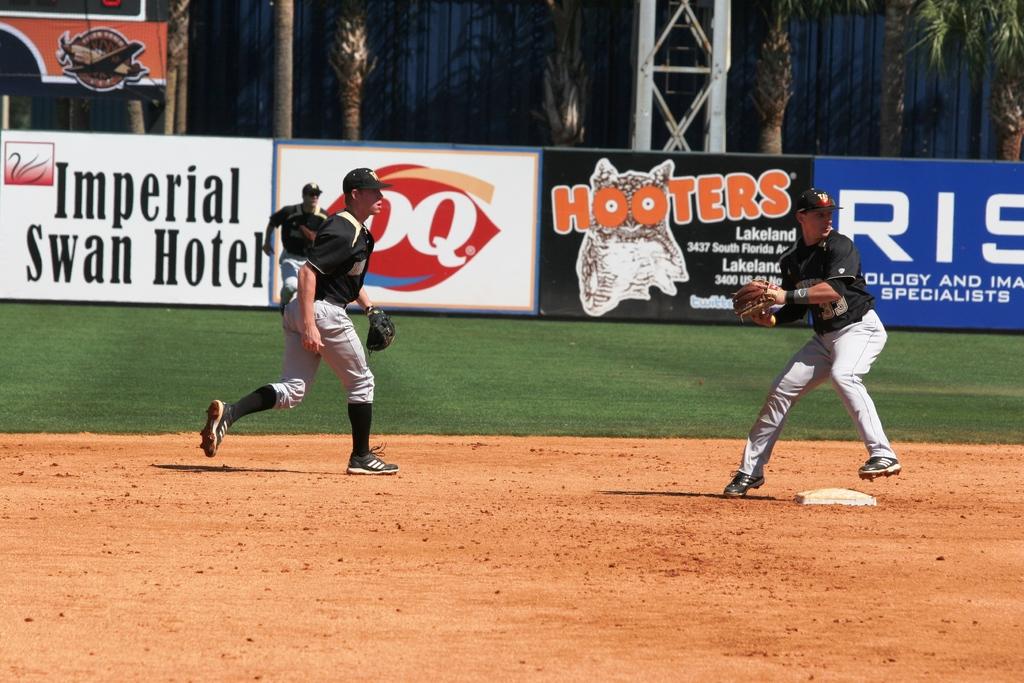What companies sponsor this event?
Ensure brevity in your answer.  Hooters. 